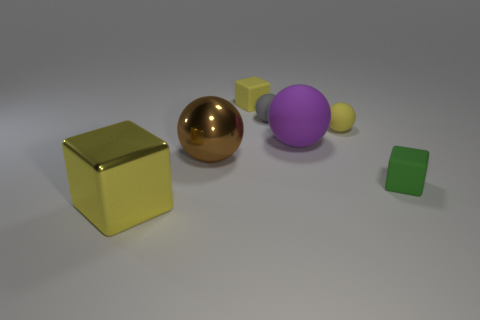There is a tiny ball that is the same color as the shiny block; what is it made of?
Ensure brevity in your answer.  Rubber. There is a matte cube that is the same color as the big metal block; what is its size?
Your response must be concise. Small. Is the large metallic block the same color as the large matte sphere?
Your answer should be compact. No. Is there any other thing that has the same material as the big purple sphere?
Your response must be concise. Yes. What shape is the large purple thing that is made of the same material as the small yellow block?
Offer a very short reply. Sphere. Is there anything else that is the same color as the large shiny ball?
Offer a very short reply. No. There is a matte block that is in front of the yellow block that is on the right side of the big brown ball; what is its color?
Offer a very short reply. Green. What is the material of the tiny cube that is in front of the small block behind the tiny block that is in front of the big brown metal sphere?
Provide a short and direct response. Rubber. What number of other spheres are the same size as the yellow ball?
Make the answer very short. 1. What is the material of the cube that is both right of the large metallic block and left of the gray rubber object?
Offer a very short reply. Rubber. 